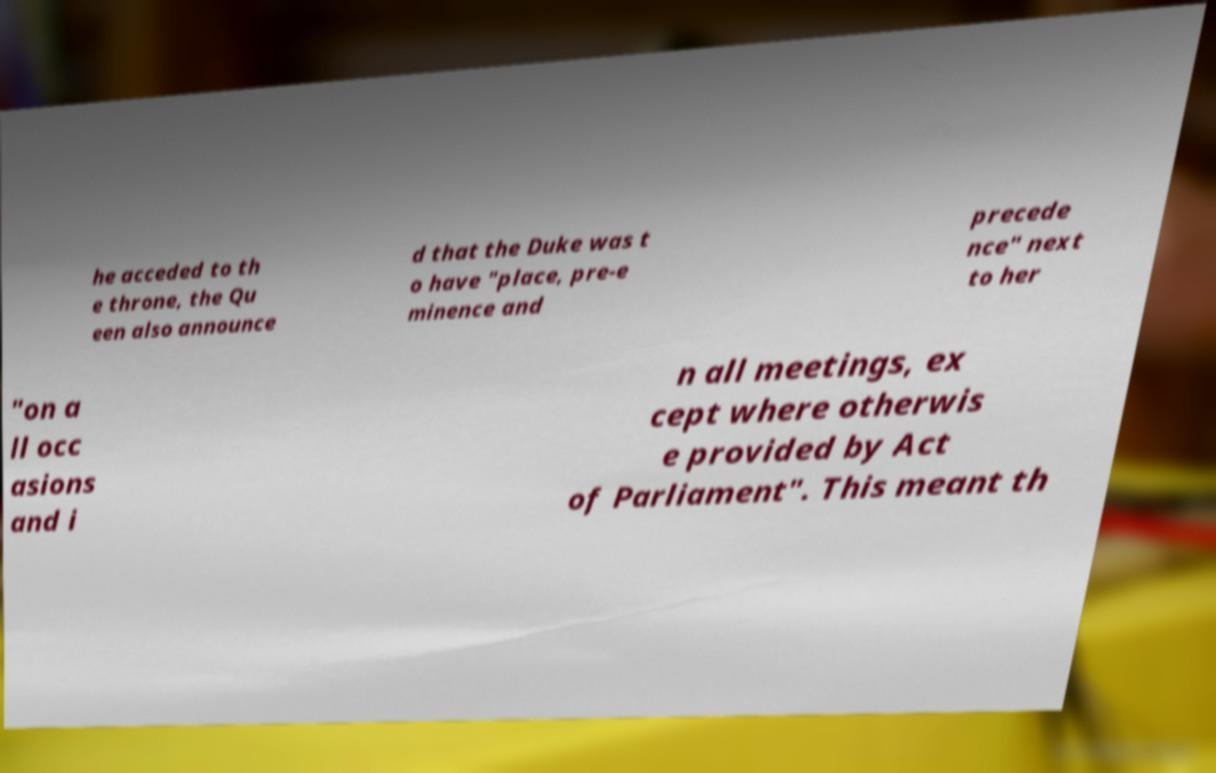For documentation purposes, I need the text within this image transcribed. Could you provide that? he acceded to th e throne, the Qu een also announce d that the Duke was t o have "place, pre-e minence and precede nce" next to her "on a ll occ asions and i n all meetings, ex cept where otherwis e provided by Act of Parliament". This meant th 